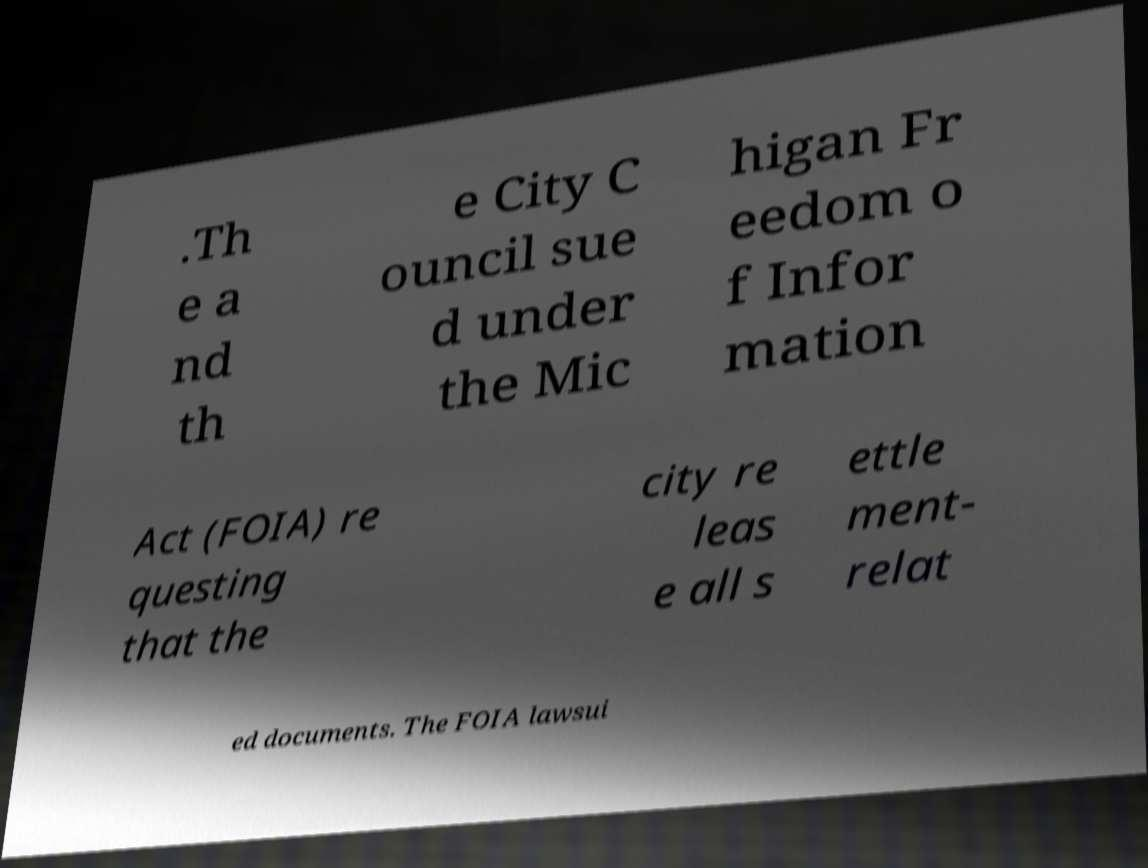Please identify and transcribe the text found in this image. .Th e a nd th e City C ouncil sue d under the Mic higan Fr eedom o f Infor mation Act (FOIA) re questing that the city re leas e all s ettle ment- relat ed documents. The FOIA lawsui 